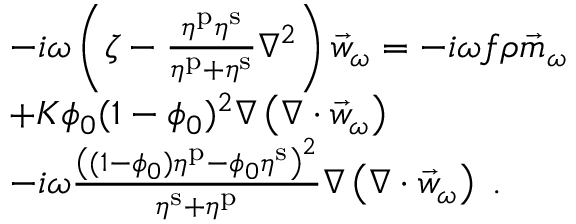<formula> <loc_0><loc_0><loc_500><loc_500>\begin{array} { r l } & { - i \omega \left ( \zeta - \frac { \eta ^ { p } \eta ^ { s } } { \eta ^ { p } + \eta ^ { s } } \nabla ^ { 2 } \right ) \vec { w } _ { \omega } = - i \omega f \rho \vec { m } _ { \omega } } \\ & { + K \phi _ { 0 } ( 1 - \phi _ { 0 } ) ^ { 2 } \nabla \left ( \nabla \cdot \vec { w } _ { \omega } \right ) } \\ & { - i \omega \frac { \left ( ( 1 - \phi _ { 0 } ) \eta ^ { p } - \phi _ { 0 } \eta ^ { s } \right ) ^ { 2 } } { \eta ^ { s } + \eta ^ { p } } \nabla \left ( \nabla \cdot \vec { w } _ { \omega } \right ) \, . } \end{array}</formula> 